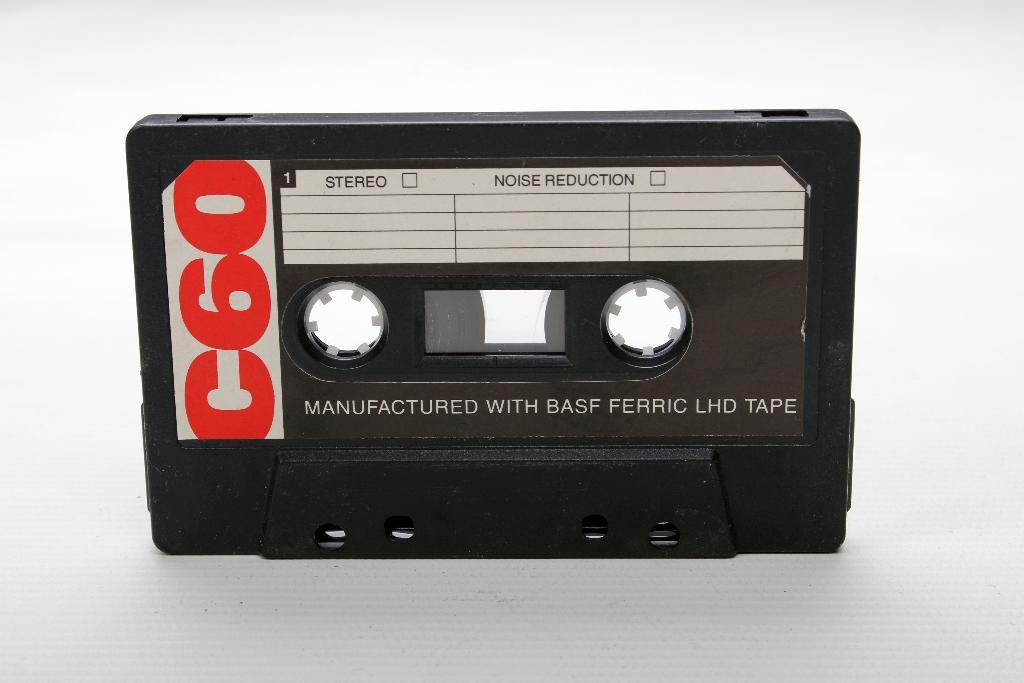Describe this image in one or two sentences. In this image, we can see a black cassette is placed on the white surface. 